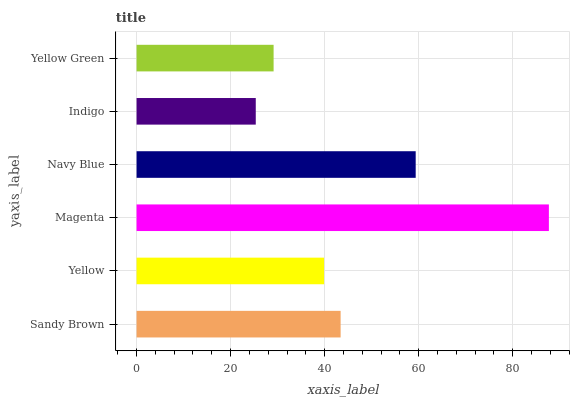Is Indigo the minimum?
Answer yes or no. Yes. Is Magenta the maximum?
Answer yes or no. Yes. Is Yellow the minimum?
Answer yes or no. No. Is Yellow the maximum?
Answer yes or no. No. Is Sandy Brown greater than Yellow?
Answer yes or no. Yes. Is Yellow less than Sandy Brown?
Answer yes or no. Yes. Is Yellow greater than Sandy Brown?
Answer yes or no. No. Is Sandy Brown less than Yellow?
Answer yes or no. No. Is Sandy Brown the high median?
Answer yes or no. Yes. Is Yellow the low median?
Answer yes or no. Yes. Is Yellow Green the high median?
Answer yes or no. No. Is Magenta the low median?
Answer yes or no. No. 